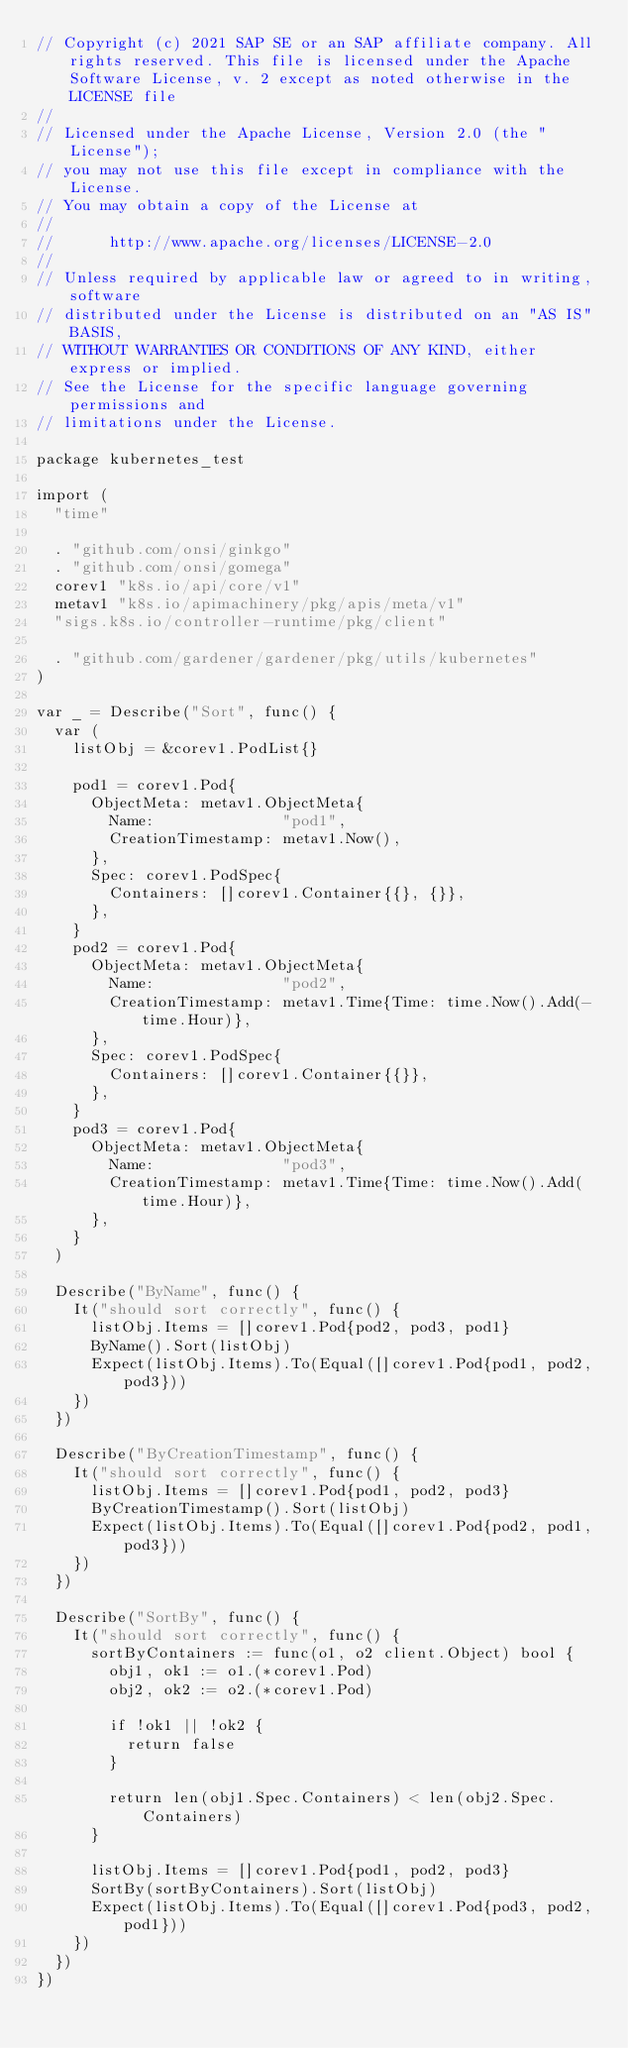Convert code to text. <code><loc_0><loc_0><loc_500><loc_500><_Go_>// Copyright (c) 2021 SAP SE or an SAP affiliate company. All rights reserved. This file is licensed under the Apache Software License, v. 2 except as noted otherwise in the LICENSE file
//
// Licensed under the Apache License, Version 2.0 (the "License");
// you may not use this file except in compliance with the License.
// You may obtain a copy of the License at
//
//      http://www.apache.org/licenses/LICENSE-2.0
//
// Unless required by applicable law or agreed to in writing, software
// distributed under the License is distributed on an "AS IS" BASIS,
// WITHOUT WARRANTIES OR CONDITIONS OF ANY KIND, either express or implied.
// See the License for the specific language governing permissions and
// limitations under the License.

package kubernetes_test

import (
	"time"

	. "github.com/onsi/ginkgo"
	. "github.com/onsi/gomega"
	corev1 "k8s.io/api/core/v1"
	metav1 "k8s.io/apimachinery/pkg/apis/meta/v1"
	"sigs.k8s.io/controller-runtime/pkg/client"

	. "github.com/gardener/gardener/pkg/utils/kubernetes"
)

var _ = Describe("Sort", func() {
	var (
		listObj = &corev1.PodList{}

		pod1 = corev1.Pod{
			ObjectMeta: metav1.ObjectMeta{
				Name:              "pod1",
				CreationTimestamp: metav1.Now(),
			},
			Spec: corev1.PodSpec{
				Containers: []corev1.Container{{}, {}},
			},
		}
		pod2 = corev1.Pod{
			ObjectMeta: metav1.ObjectMeta{
				Name:              "pod2",
				CreationTimestamp: metav1.Time{Time: time.Now().Add(-time.Hour)},
			},
			Spec: corev1.PodSpec{
				Containers: []corev1.Container{{}},
			},
		}
		pod3 = corev1.Pod{
			ObjectMeta: metav1.ObjectMeta{
				Name:              "pod3",
				CreationTimestamp: metav1.Time{Time: time.Now().Add(time.Hour)},
			},
		}
	)

	Describe("ByName", func() {
		It("should sort correctly", func() {
			listObj.Items = []corev1.Pod{pod2, pod3, pod1}
			ByName().Sort(listObj)
			Expect(listObj.Items).To(Equal([]corev1.Pod{pod1, pod2, pod3}))
		})
	})

	Describe("ByCreationTimestamp", func() {
		It("should sort correctly", func() {
			listObj.Items = []corev1.Pod{pod1, pod2, pod3}
			ByCreationTimestamp().Sort(listObj)
			Expect(listObj.Items).To(Equal([]corev1.Pod{pod2, pod1, pod3}))
		})
	})

	Describe("SortBy", func() {
		It("should sort correctly", func() {
			sortByContainers := func(o1, o2 client.Object) bool {
				obj1, ok1 := o1.(*corev1.Pod)
				obj2, ok2 := o2.(*corev1.Pod)

				if !ok1 || !ok2 {
					return false
				}

				return len(obj1.Spec.Containers) < len(obj2.Spec.Containers)
			}

			listObj.Items = []corev1.Pod{pod1, pod2, pod3}
			SortBy(sortByContainers).Sort(listObj)
			Expect(listObj.Items).To(Equal([]corev1.Pod{pod3, pod2, pod1}))
		})
	})
})
</code> 